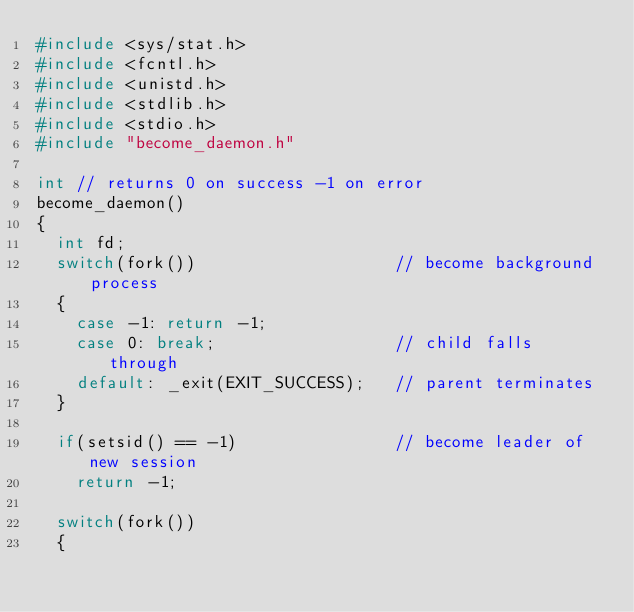<code> <loc_0><loc_0><loc_500><loc_500><_C_>#include <sys/stat.h>
#include <fcntl.h>
#include <unistd.h>
#include <stdlib.h>
#include <stdio.h>
#include "become_daemon.h"

int // returns 0 on success -1 on error
become_daemon()
{
  int fd;
  switch(fork())                    // become background process
  {
    case -1: return -1;
    case 0: break;                  // child falls through
    default: _exit(EXIT_SUCCESS);   // parent terminates
  }

  if(setsid() == -1)                // become leader of new session
    return -1;

  switch(fork())
  {</code> 